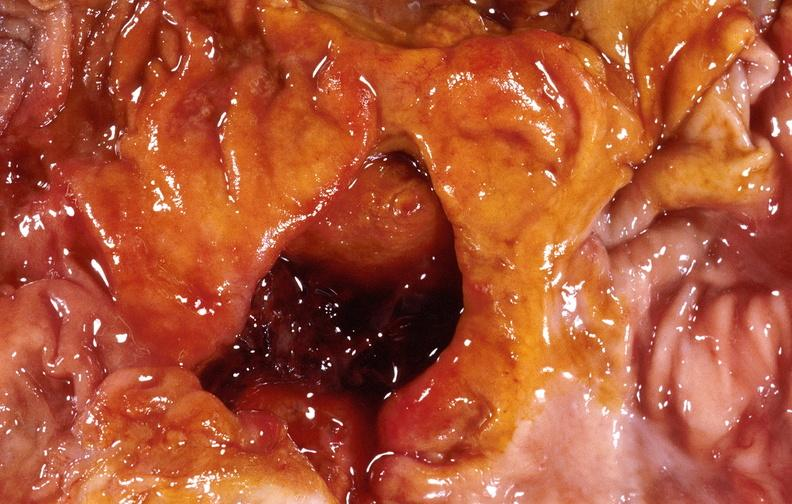does adenocarcinoma show duodenal ulcer?
Answer the question using a single word or phrase. No 